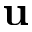<formula> <loc_0><loc_0><loc_500><loc_500>u</formula> 